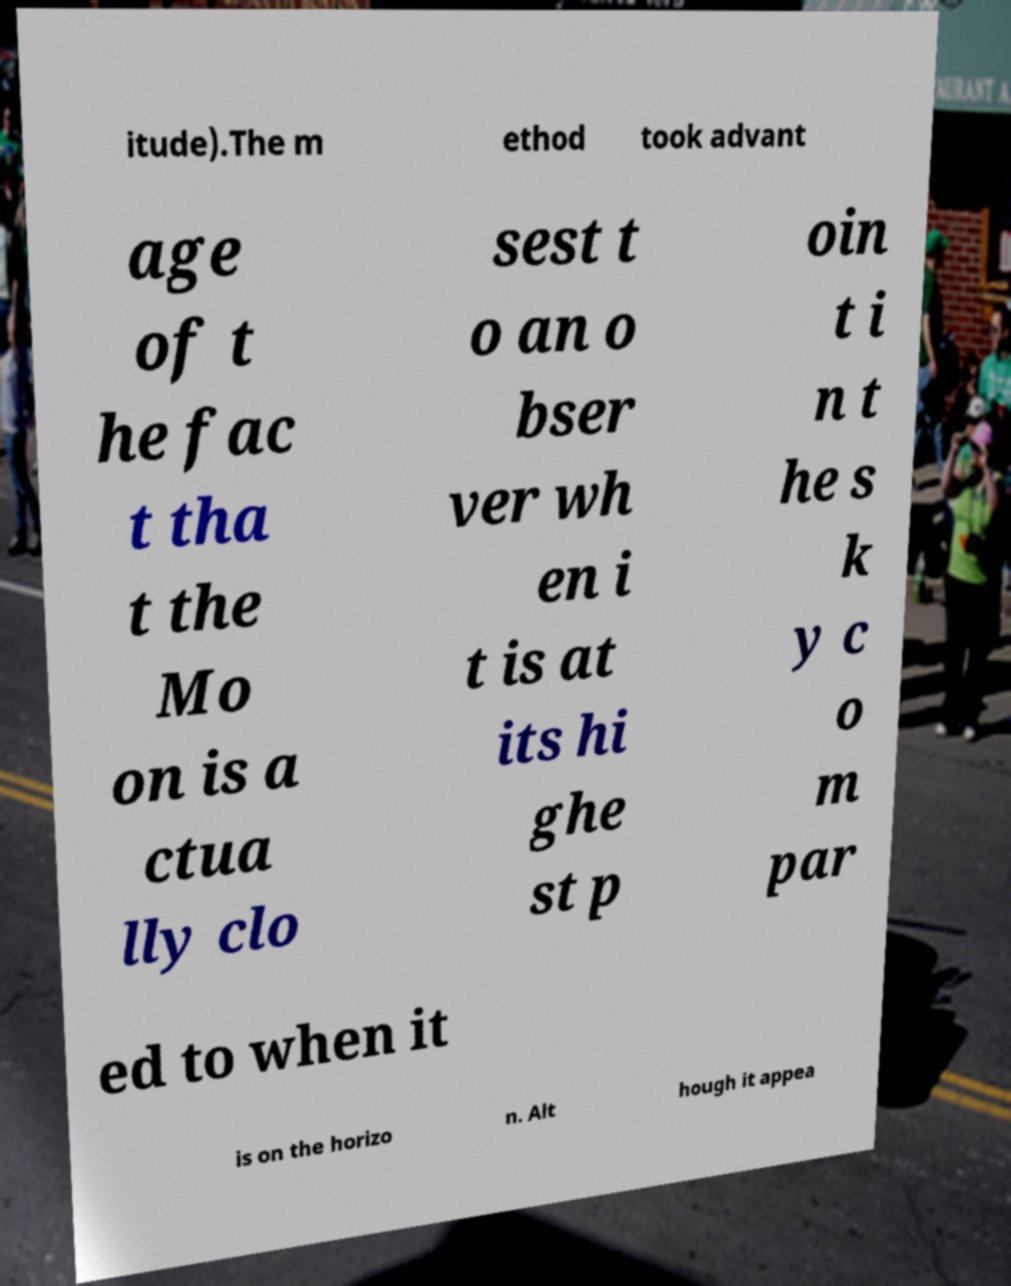I need the written content from this picture converted into text. Can you do that? itude).The m ethod took advant age of t he fac t tha t the Mo on is a ctua lly clo sest t o an o bser ver wh en i t is at its hi ghe st p oin t i n t he s k y c o m par ed to when it is on the horizo n. Alt hough it appea 